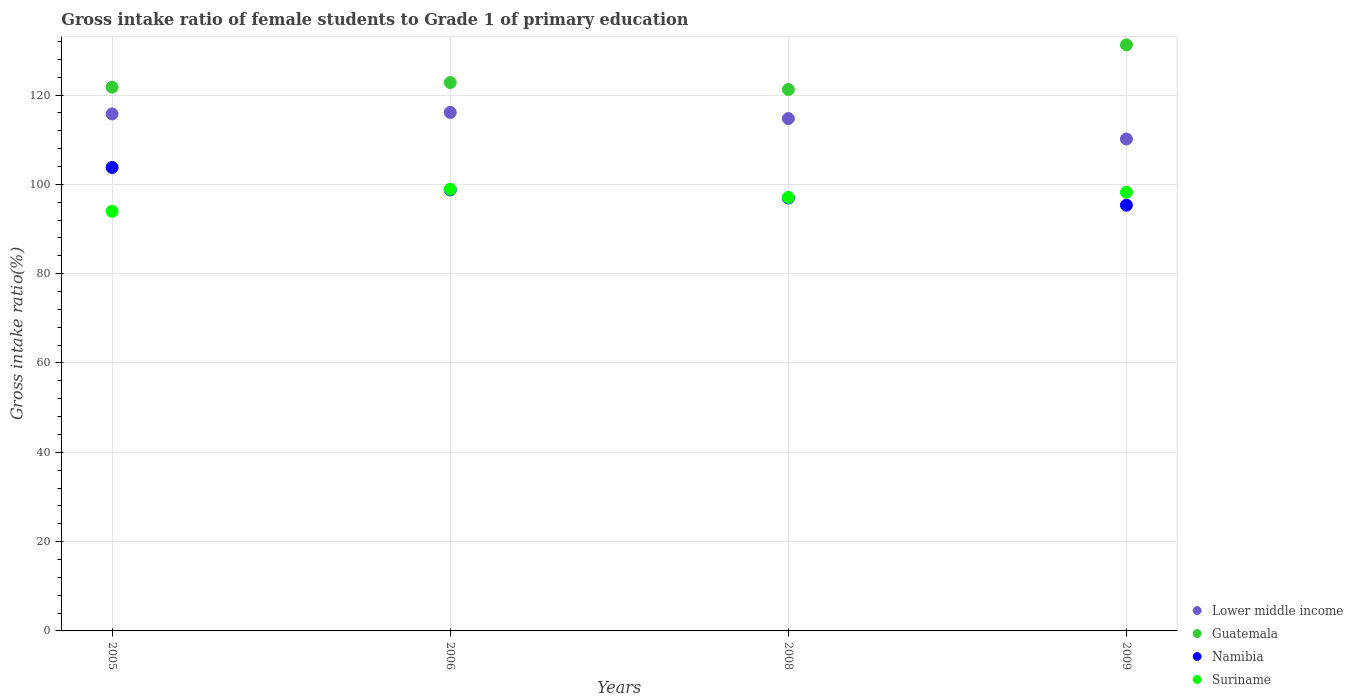What is the gross intake ratio in Guatemala in 2005?
Your answer should be very brief. 121.76. Across all years, what is the maximum gross intake ratio in Suriname?
Ensure brevity in your answer.  98.91. Across all years, what is the minimum gross intake ratio in Guatemala?
Provide a succinct answer. 121.24. In which year was the gross intake ratio in Lower middle income minimum?
Your response must be concise. 2009. What is the total gross intake ratio in Guatemala in the graph?
Make the answer very short. 497.03. What is the difference between the gross intake ratio in Suriname in 2005 and that in 2009?
Ensure brevity in your answer.  -4.27. What is the difference between the gross intake ratio in Namibia in 2008 and the gross intake ratio in Suriname in 2009?
Keep it short and to the point. -1.28. What is the average gross intake ratio in Suriname per year?
Your response must be concise. 97.05. In the year 2005, what is the difference between the gross intake ratio in Suriname and gross intake ratio in Guatemala?
Give a very brief answer. -27.8. What is the ratio of the gross intake ratio in Lower middle income in 2005 to that in 2008?
Your response must be concise. 1.01. Is the gross intake ratio in Namibia in 2005 less than that in 2008?
Your answer should be very brief. No. Is the difference between the gross intake ratio in Suriname in 2008 and 2009 greater than the difference between the gross intake ratio in Guatemala in 2008 and 2009?
Offer a terse response. Yes. What is the difference between the highest and the second highest gross intake ratio in Lower middle income?
Your response must be concise. 0.34. What is the difference between the highest and the lowest gross intake ratio in Suriname?
Provide a succinct answer. 4.95. Is the sum of the gross intake ratio in Suriname in 2005 and 2006 greater than the maximum gross intake ratio in Lower middle income across all years?
Your answer should be compact. Yes. Is it the case that in every year, the sum of the gross intake ratio in Suriname and gross intake ratio in Lower middle income  is greater than the sum of gross intake ratio in Guatemala and gross intake ratio in Namibia?
Offer a terse response. No. Is it the case that in every year, the sum of the gross intake ratio in Namibia and gross intake ratio in Suriname  is greater than the gross intake ratio in Guatemala?
Ensure brevity in your answer.  Yes. Does the gross intake ratio in Namibia monotonically increase over the years?
Offer a terse response. No. Is the gross intake ratio in Lower middle income strictly less than the gross intake ratio in Namibia over the years?
Keep it short and to the point. No. How many dotlines are there?
Your response must be concise. 4. What is the difference between two consecutive major ticks on the Y-axis?
Ensure brevity in your answer.  20. Where does the legend appear in the graph?
Offer a very short reply. Bottom right. How many legend labels are there?
Provide a short and direct response. 4. How are the legend labels stacked?
Give a very brief answer. Vertical. What is the title of the graph?
Make the answer very short. Gross intake ratio of female students to Grade 1 of primary education. What is the label or title of the Y-axis?
Ensure brevity in your answer.  Gross intake ratio(%). What is the Gross intake ratio(%) of Lower middle income in 2005?
Offer a very short reply. 115.78. What is the Gross intake ratio(%) in Guatemala in 2005?
Keep it short and to the point. 121.76. What is the Gross intake ratio(%) of Namibia in 2005?
Your answer should be compact. 103.78. What is the Gross intake ratio(%) in Suriname in 2005?
Your answer should be very brief. 93.96. What is the Gross intake ratio(%) of Lower middle income in 2006?
Offer a very short reply. 116.11. What is the Gross intake ratio(%) of Guatemala in 2006?
Your answer should be very brief. 122.8. What is the Gross intake ratio(%) in Namibia in 2006?
Offer a very short reply. 98.77. What is the Gross intake ratio(%) of Suriname in 2006?
Ensure brevity in your answer.  98.91. What is the Gross intake ratio(%) in Lower middle income in 2008?
Offer a very short reply. 114.73. What is the Gross intake ratio(%) of Guatemala in 2008?
Keep it short and to the point. 121.24. What is the Gross intake ratio(%) of Namibia in 2008?
Provide a short and direct response. 96.95. What is the Gross intake ratio(%) of Suriname in 2008?
Keep it short and to the point. 97.08. What is the Gross intake ratio(%) in Lower middle income in 2009?
Provide a short and direct response. 110.15. What is the Gross intake ratio(%) in Guatemala in 2009?
Ensure brevity in your answer.  131.23. What is the Gross intake ratio(%) of Namibia in 2009?
Offer a terse response. 95.34. What is the Gross intake ratio(%) in Suriname in 2009?
Offer a terse response. 98.23. Across all years, what is the maximum Gross intake ratio(%) of Lower middle income?
Offer a terse response. 116.11. Across all years, what is the maximum Gross intake ratio(%) of Guatemala?
Keep it short and to the point. 131.23. Across all years, what is the maximum Gross intake ratio(%) in Namibia?
Offer a terse response. 103.78. Across all years, what is the maximum Gross intake ratio(%) of Suriname?
Provide a short and direct response. 98.91. Across all years, what is the minimum Gross intake ratio(%) of Lower middle income?
Offer a terse response. 110.15. Across all years, what is the minimum Gross intake ratio(%) in Guatemala?
Ensure brevity in your answer.  121.24. Across all years, what is the minimum Gross intake ratio(%) of Namibia?
Provide a succinct answer. 95.34. Across all years, what is the minimum Gross intake ratio(%) of Suriname?
Make the answer very short. 93.96. What is the total Gross intake ratio(%) in Lower middle income in the graph?
Ensure brevity in your answer.  456.77. What is the total Gross intake ratio(%) of Guatemala in the graph?
Your response must be concise. 497.03. What is the total Gross intake ratio(%) of Namibia in the graph?
Give a very brief answer. 394.85. What is the total Gross intake ratio(%) of Suriname in the graph?
Keep it short and to the point. 388.18. What is the difference between the Gross intake ratio(%) of Lower middle income in 2005 and that in 2006?
Give a very brief answer. -0.34. What is the difference between the Gross intake ratio(%) in Guatemala in 2005 and that in 2006?
Make the answer very short. -1.05. What is the difference between the Gross intake ratio(%) of Namibia in 2005 and that in 2006?
Make the answer very short. 5.01. What is the difference between the Gross intake ratio(%) in Suriname in 2005 and that in 2006?
Give a very brief answer. -4.95. What is the difference between the Gross intake ratio(%) of Lower middle income in 2005 and that in 2008?
Your answer should be compact. 1.05. What is the difference between the Gross intake ratio(%) of Guatemala in 2005 and that in 2008?
Give a very brief answer. 0.52. What is the difference between the Gross intake ratio(%) of Namibia in 2005 and that in 2008?
Your answer should be very brief. 6.83. What is the difference between the Gross intake ratio(%) of Suriname in 2005 and that in 2008?
Your answer should be compact. -3.12. What is the difference between the Gross intake ratio(%) of Lower middle income in 2005 and that in 2009?
Your answer should be very brief. 5.63. What is the difference between the Gross intake ratio(%) in Guatemala in 2005 and that in 2009?
Offer a very short reply. -9.47. What is the difference between the Gross intake ratio(%) of Namibia in 2005 and that in 2009?
Offer a terse response. 8.44. What is the difference between the Gross intake ratio(%) in Suriname in 2005 and that in 2009?
Provide a succinct answer. -4.27. What is the difference between the Gross intake ratio(%) in Lower middle income in 2006 and that in 2008?
Provide a short and direct response. 1.38. What is the difference between the Gross intake ratio(%) in Guatemala in 2006 and that in 2008?
Provide a succinct answer. 1.57. What is the difference between the Gross intake ratio(%) of Namibia in 2006 and that in 2008?
Your answer should be compact. 1.82. What is the difference between the Gross intake ratio(%) in Suriname in 2006 and that in 2008?
Make the answer very short. 1.83. What is the difference between the Gross intake ratio(%) of Lower middle income in 2006 and that in 2009?
Your answer should be compact. 5.96. What is the difference between the Gross intake ratio(%) in Guatemala in 2006 and that in 2009?
Make the answer very short. -8.43. What is the difference between the Gross intake ratio(%) in Namibia in 2006 and that in 2009?
Your response must be concise. 3.43. What is the difference between the Gross intake ratio(%) of Suriname in 2006 and that in 2009?
Your response must be concise. 0.68. What is the difference between the Gross intake ratio(%) of Lower middle income in 2008 and that in 2009?
Offer a terse response. 4.58. What is the difference between the Gross intake ratio(%) in Guatemala in 2008 and that in 2009?
Your response must be concise. -9.99. What is the difference between the Gross intake ratio(%) of Namibia in 2008 and that in 2009?
Your answer should be compact. 1.62. What is the difference between the Gross intake ratio(%) in Suriname in 2008 and that in 2009?
Keep it short and to the point. -1.15. What is the difference between the Gross intake ratio(%) in Lower middle income in 2005 and the Gross intake ratio(%) in Guatemala in 2006?
Give a very brief answer. -7.03. What is the difference between the Gross intake ratio(%) of Lower middle income in 2005 and the Gross intake ratio(%) of Namibia in 2006?
Your answer should be compact. 17. What is the difference between the Gross intake ratio(%) in Lower middle income in 2005 and the Gross intake ratio(%) in Suriname in 2006?
Offer a terse response. 16.86. What is the difference between the Gross intake ratio(%) of Guatemala in 2005 and the Gross intake ratio(%) of Namibia in 2006?
Your answer should be compact. 22.98. What is the difference between the Gross intake ratio(%) in Guatemala in 2005 and the Gross intake ratio(%) in Suriname in 2006?
Offer a very short reply. 22.84. What is the difference between the Gross intake ratio(%) of Namibia in 2005 and the Gross intake ratio(%) of Suriname in 2006?
Offer a terse response. 4.87. What is the difference between the Gross intake ratio(%) of Lower middle income in 2005 and the Gross intake ratio(%) of Guatemala in 2008?
Ensure brevity in your answer.  -5.46. What is the difference between the Gross intake ratio(%) of Lower middle income in 2005 and the Gross intake ratio(%) of Namibia in 2008?
Ensure brevity in your answer.  18.82. What is the difference between the Gross intake ratio(%) in Lower middle income in 2005 and the Gross intake ratio(%) in Suriname in 2008?
Make the answer very short. 18.7. What is the difference between the Gross intake ratio(%) of Guatemala in 2005 and the Gross intake ratio(%) of Namibia in 2008?
Keep it short and to the point. 24.8. What is the difference between the Gross intake ratio(%) in Guatemala in 2005 and the Gross intake ratio(%) in Suriname in 2008?
Provide a short and direct response. 24.68. What is the difference between the Gross intake ratio(%) of Namibia in 2005 and the Gross intake ratio(%) of Suriname in 2008?
Your answer should be very brief. 6.71. What is the difference between the Gross intake ratio(%) in Lower middle income in 2005 and the Gross intake ratio(%) in Guatemala in 2009?
Keep it short and to the point. -15.45. What is the difference between the Gross intake ratio(%) in Lower middle income in 2005 and the Gross intake ratio(%) in Namibia in 2009?
Provide a short and direct response. 20.44. What is the difference between the Gross intake ratio(%) of Lower middle income in 2005 and the Gross intake ratio(%) of Suriname in 2009?
Offer a very short reply. 17.55. What is the difference between the Gross intake ratio(%) of Guatemala in 2005 and the Gross intake ratio(%) of Namibia in 2009?
Make the answer very short. 26.42. What is the difference between the Gross intake ratio(%) in Guatemala in 2005 and the Gross intake ratio(%) in Suriname in 2009?
Give a very brief answer. 23.53. What is the difference between the Gross intake ratio(%) in Namibia in 2005 and the Gross intake ratio(%) in Suriname in 2009?
Your answer should be very brief. 5.55. What is the difference between the Gross intake ratio(%) of Lower middle income in 2006 and the Gross intake ratio(%) of Guatemala in 2008?
Ensure brevity in your answer.  -5.13. What is the difference between the Gross intake ratio(%) of Lower middle income in 2006 and the Gross intake ratio(%) of Namibia in 2008?
Keep it short and to the point. 19.16. What is the difference between the Gross intake ratio(%) in Lower middle income in 2006 and the Gross intake ratio(%) in Suriname in 2008?
Offer a very short reply. 19.03. What is the difference between the Gross intake ratio(%) of Guatemala in 2006 and the Gross intake ratio(%) of Namibia in 2008?
Keep it short and to the point. 25.85. What is the difference between the Gross intake ratio(%) in Guatemala in 2006 and the Gross intake ratio(%) in Suriname in 2008?
Make the answer very short. 25.73. What is the difference between the Gross intake ratio(%) of Namibia in 2006 and the Gross intake ratio(%) of Suriname in 2008?
Keep it short and to the point. 1.69. What is the difference between the Gross intake ratio(%) in Lower middle income in 2006 and the Gross intake ratio(%) in Guatemala in 2009?
Provide a succinct answer. -15.12. What is the difference between the Gross intake ratio(%) of Lower middle income in 2006 and the Gross intake ratio(%) of Namibia in 2009?
Provide a short and direct response. 20.77. What is the difference between the Gross intake ratio(%) in Lower middle income in 2006 and the Gross intake ratio(%) in Suriname in 2009?
Offer a very short reply. 17.88. What is the difference between the Gross intake ratio(%) of Guatemala in 2006 and the Gross intake ratio(%) of Namibia in 2009?
Provide a succinct answer. 27.47. What is the difference between the Gross intake ratio(%) of Guatemala in 2006 and the Gross intake ratio(%) of Suriname in 2009?
Offer a terse response. 24.57. What is the difference between the Gross intake ratio(%) of Namibia in 2006 and the Gross intake ratio(%) of Suriname in 2009?
Offer a very short reply. 0.54. What is the difference between the Gross intake ratio(%) of Lower middle income in 2008 and the Gross intake ratio(%) of Guatemala in 2009?
Your response must be concise. -16.5. What is the difference between the Gross intake ratio(%) of Lower middle income in 2008 and the Gross intake ratio(%) of Namibia in 2009?
Make the answer very short. 19.39. What is the difference between the Gross intake ratio(%) in Lower middle income in 2008 and the Gross intake ratio(%) in Suriname in 2009?
Your answer should be compact. 16.5. What is the difference between the Gross intake ratio(%) of Guatemala in 2008 and the Gross intake ratio(%) of Namibia in 2009?
Your answer should be compact. 25.9. What is the difference between the Gross intake ratio(%) in Guatemala in 2008 and the Gross intake ratio(%) in Suriname in 2009?
Offer a very short reply. 23.01. What is the difference between the Gross intake ratio(%) of Namibia in 2008 and the Gross intake ratio(%) of Suriname in 2009?
Give a very brief answer. -1.28. What is the average Gross intake ratio(%) in Lower middle income per year?
Ensure brevity in your answer.  114.19. What is the average Gross intake ratio(%) of Guatemala per year?
Provide a succinct answer. 124.26. What is the average Gross intake ratio(%) of Namibia per year?
Keep it short and to the point. 98.71. What is the average Gross intake ratio(%) in Suriname per year?
Provide a short and direct response. 97.05. In the year 2005, what is the difference between the Gross intake ratio(%) of Lower middle income and Gross intake ratio(%) of Guatemala?
Your response must be concise. -5.98. In the year 2005, what is the difference between the Gross intake ratio(%) of Lower middle income and Gross intake ratio(%) of Namibia?
Your answer should be very brief. 11.99. In the year 2005, what is the difference between the Gross intake ratio(%) of Lower middle income and Gross intake ratio(%) of Suriname?
Your answer should be compact. 21.82. In the year 2005, what is the difference between the Gross intake ratio(%) in Guatemala and Gross intake ratio(%) in Namibia?
Provide a succinct answer. 17.97. In the year 2005, what is the difference between the Gross intake ratio(%) of Guatemala and Gross intake ratio(%) of Suriname?
Offer a terse response. 27.8. In the year 2005, what is the difference between the Gross intake ratio(%) in Namibia and Gross intake ratio(%) in Suriname?
Keep it short and to the point. 9.82. In the year 2006, what is the difference between the Gross intake ratio(%) of Lower middle income and Gross intake ratio(%) of Guatemala?
Your response must be concise. -6.69. In the year 2006, what is the difference between the Gross intake ratio(%) in Lower middle income and Gross intake ratio(%) in Namibia?
Provide a succinct answer. 17.34. In the year 2006, what is the difference between the Gross intake ratio(%) of Lower middle income and Gross intake ratio(%) of Suriname?
Offer a very short reply. 17.2. In the year 2006, what is the difference between the Gross intake ratio(%) of Guatemala and Gross intake ratio(%) of Namibia?
Provide a succinct answer. 24.03. In the year 2006, what is the difference between the Gross intake ratio(%) of Guatemala and Gross intake ratio(%) of Suriname?
Your answer should be compact. 23.89. In the year 2006, what is the difference between the Gross intake ratio(%) in Namibia and Gross intake ratio(%) in Suriname?
Your response must be concise. -0.14. In the year 2008, what is the difference between the Gross intake ratio(%) of Lower middle income and Gross intake ratio(%) of Guatemala?
Provide a short and direct response. -6.51. In the year 2008, what is the difference between the Gross intake ratio(%) of Lower middle income and Gross intake ratio(%) of Namibia?
Offer a very short reply. 17.78. In the year 2008, what is the difference between the Gross intake ratio(%) in Lower middle income and Gross intake ratio(%) in Suriname?
Offer a terse response. 17.65. In the year 2008, what is the difference between the Gross intake ratio(%) in Guatemala and Gross intake ratio(%) in Namibia?
Keep it short and to the point. 24.28. In the year 2008, what is the difference between the Gross intake ratio(%) in Guatemala and Gross intake ratio(%) in Suriname?
Your response must be concise. 24.16. In the year 2008, what is the difference between the Gross intake ratio(%) of Namibia and Gross intake ratio(%) of Suriname?
Provide a succinct answer. -0.12. In the year 2009, what is the difference between the Gross intake ratio(%) of Lower middle income and Gross intake ratio(%) of Guatemala?
Offer a terse response. -21.08. In the year 2009, what is the difference between the Gross intake ratio(%) in Lower middle income and Gross intake ratio(%) in Namibia?
Offer a very short reply. 14.81. In the year 2009, what is the difference between the Gross intake ratio(%) in Lower middle income and Gross intake ratio(%) in Suriname?
Provide a succinct answer. 11.92. In the year 2009, what is the difference between the Gross intake ratio(%) of Guatemala and Gross intake ratio(%) of Namibia?
Provide a short and direct response. 35.89. In the year 2009, what is the difference between the Gross intake ratio(%) in Guatemala and Gross intake ratio(%) in Suriname?
Your response must be concise. 33. In the year 2009, what is the difference between the Gross intake ratio(%) in Namibia and Gross intake ratio(%) in Suriname?
Your answer should be very brief. -2.89. What is the ratio of the Gross intake ratio(%) in Namibia in 2005 to that in 2006?
Give a very brief answer. 1.05. What is the ratio of the Gross intake ratio(%) in Suriname in 2005 to that in 2006?
Your answer should be very brief. 0.95. What is the ratio of the Gross intake ratio(%) of Lower middle income in 2005 to that in 2008?
Give a very brief answer. 1.01. What is the ratio of the Gross intake ratio(%) of Guatemala in 2005 to that in 2008?
Your answer should be very brief. 1. What is the ratio of the Gross intake ratio(%) in Namibia in 2005 to that in 2008?
Make the answer very short. 1.07. What is the ratio of the Gross intake ratio(%) in Suriname in 2005 to that in 2008?
Offer a terse response. 0.97. What is the ratio of the Gross intake ratio(%) in Lower middle income in 2005 to that in 2009?
Provide a short and direct response. 1.05. What is the ratio of the Gross intake ratio(%) in Guatemala in 2005 to that in 2009?
Keep it short and to the point. 0.93. What is the ratio of the Gross intake ratio(%) in Namibia in 2005 to that in 2009?
Make the answer very short. 1.09. What is the ratio of the Gross intake ratio(%) of Suriname in 2005 to that in 2009?
Give a very brief answer. 0.96. What is the ratio of the Gross intake ratio(%) in Guatemala in 2006 to that in 2008?
Ensure brevity in your answer.  1.01. What is the ratio of the Gross intake ratio(%) of Namibia in 2006 to that in 2008?
Make the answer very short. 1.02. What is the ratio of the Gross intake ratio(%) in Suriname in 2006 to that in 2008?
Keep it short and to the point. 1.02. What is the ratio of the Gross intake ratio(%) of Lower middle income in 2006 to that in 2009?
Keep it short and to the point. 1.05. What is the ratio of the Gross intake ratio(%) of Guatemala in 2006 to that in 2009?
Provide a succinct answer. 0.94. What is the ratio of the Gross intake ratio(%) of Namibia in 2006 to that in 2009?
Provide a succinct answer. 1.04. What is the ratio of the Gross intake ratio(%) of Lower middle income in 2008 to that in 2009?
Offer a terse response. 1.04. What is the ratio of the Gross intake ratio(%) of Guatemala in 2008 to that in 2009?
Your answer should be very brief. 0.92. What is the ratio of the Gross intake ratio(%) of Namibia in 2008 to that in 2009?
Ensure brevity in your answer.  1.02. What is the ratio of the Gross intake ratio(%) in Suriname in 2008 to that in 2009?
Your response must be concise. 0.99. What is the difference between the highest and the second highest Gross intake ratio(%) of Lower middle income?
Provide a succinct answer. 0.34. What is the difference between the highest and the second highest Gross intake ratio(%) in Guatemala?
Ensure brevity in your answer.  8.43. What is the difference between the highest and the second highest Gross intake ratio(%) of Namibia?
Make the answer very short. 5.01. What is the difference between the highest and the second highest Gross intake ratio(%) of Suriname?
Provide a short and direct response. 0.68. What is the difference between the highest and the lowest Gross intake ratio(%) in Lower middle income?
Offer a very short reply. 5.96. What is the difference between the highest and the lowest Gross intake ratio(%) in Guatemala?
Offer a terse response. 9.99. What is the difference between the highest and the lowest Gross intake ratio(%) in Namibia?
Your answer should be very brief. 8.44. What is the difference between the highest and the lowest Gross intake ratio(%) in Suriname?
Give a very brief answer. 4.95. 